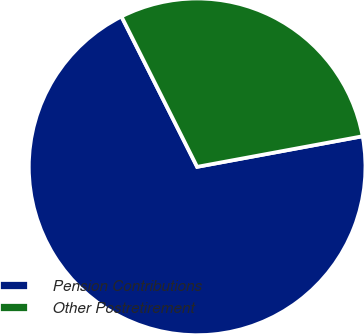Convert chart. <chart><loc_0><loc_0><loc_500><loc_500><pie_chart><fcel>Pension Contributions<fcel>Other Postretirement<nl><fcel>70.49%<fcel>29.51%<nl></chart> 